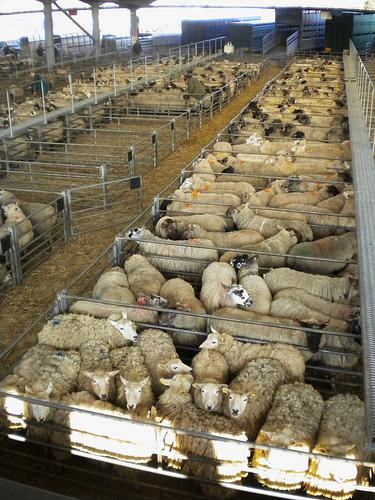Question: who is present?
Choices:
A. Nobody.
B. A man.
C. A woman.
D. A family.
Answer with the letter. Answer: A Question: what are they?
Choices:
A. Dog.
B. Sheep.
C. Cat.
D. Goat.
Answer with the letter. Answer: B Question: what are they doing?
Choices:
A. Sleeping.
B. Moving.
C. Standing.
D. Resting.
Answer with the letter. Answer: B Question: how many are they?
Choices:
A. 50 and above.
B. 40.
C. 20.
D. 25.
Answer with the letter. Answer: A 